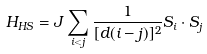Convert formula to latex. <formula><loc_0><loc_0><loc_500><loc_500>H _ { H S } = J \sum _ { i < j } \frac { 1 } { [ d ( i - j ) ] ^ { 2 } } S _ { i } \cdot S _ { j }</formula> 